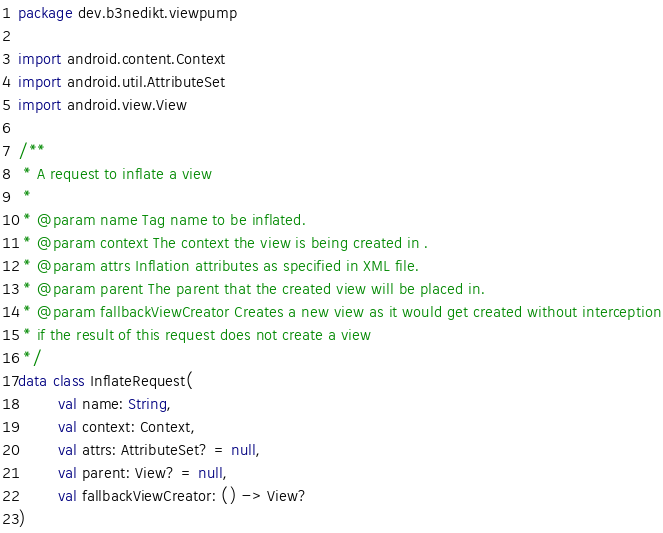<code> <loc_0><loc_0><loc_500><loc_500><_Kotlin_>package dev.b3nedikt.viewpump

import android.content.Context
import android.util.AttributeSet
import android.view.View

/**
 * A request to inflate a view
 *
 * @param name Tag name to be inflated.
 * @param context The context the view is being created in .
 * @param attrs Inflation attributes as specified in XML file.
 * @param parent The parent that the created view will be placed in.
 * @param fallbackViewCreator Creates a new view as it would get created without interception
 * if the result of this request does not create a view
 */
data class InflateRequest(
        val name: String,
        val context: Context,
        val attrs: AttributeSet? = null,
        val parent: View? = null,
        val fallbackViewCreator: () -> View?
)</code> 